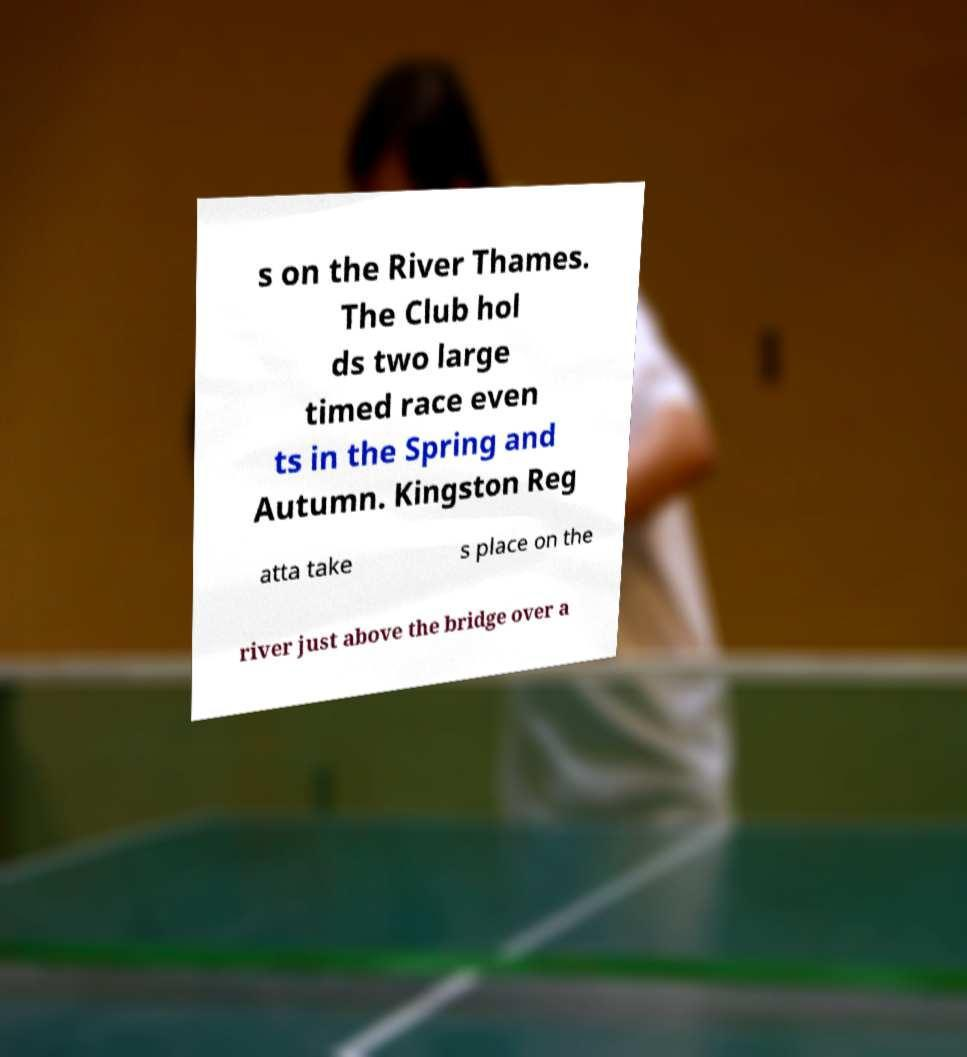Can you read and provide the text displayed in the image?This photo seems to have some interesting text. Can you extract and type it out for me? s on the River Thames. The Club hol ds two large timed race even ts in the Spring and Autumn. Kingston Reg atta take s place on the river just above the bridge over a 